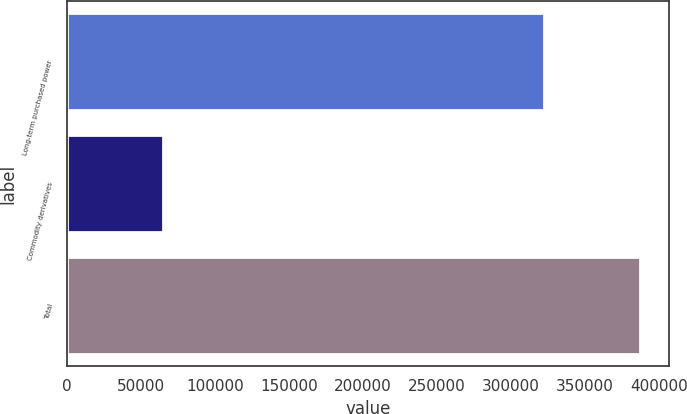Convert chart to OTSL. <chart><loc_0><loc_0><loc_500><loc_500><bar_chart><fcel>Long-term purchased power<fcel>Commodity derivatives<fcel>Total<nl><fcel>322455<fcel>64775<fcel>387230<nl></chart> 